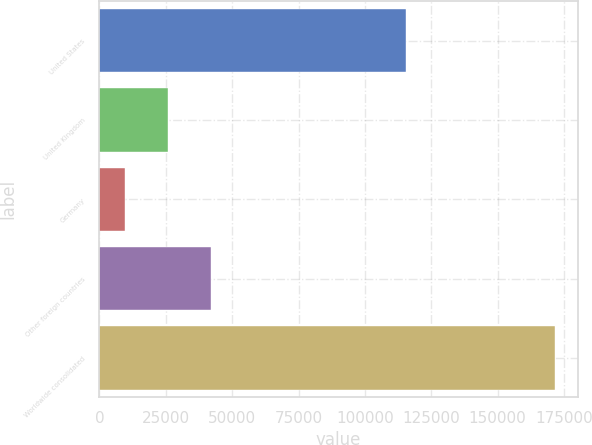<chart> <loc_0><loc_0><loc_500><loc_500><bar_chart><fcel>United States<fcel>United Kingdom<fcel>Germany<fcel>Other foreign countries<fcel>Worldwide consolidated<nl><fcel>115378<fcel>25978.7<fcel>9799<fcel>42158.4<fcel>171596<nl></chart> 